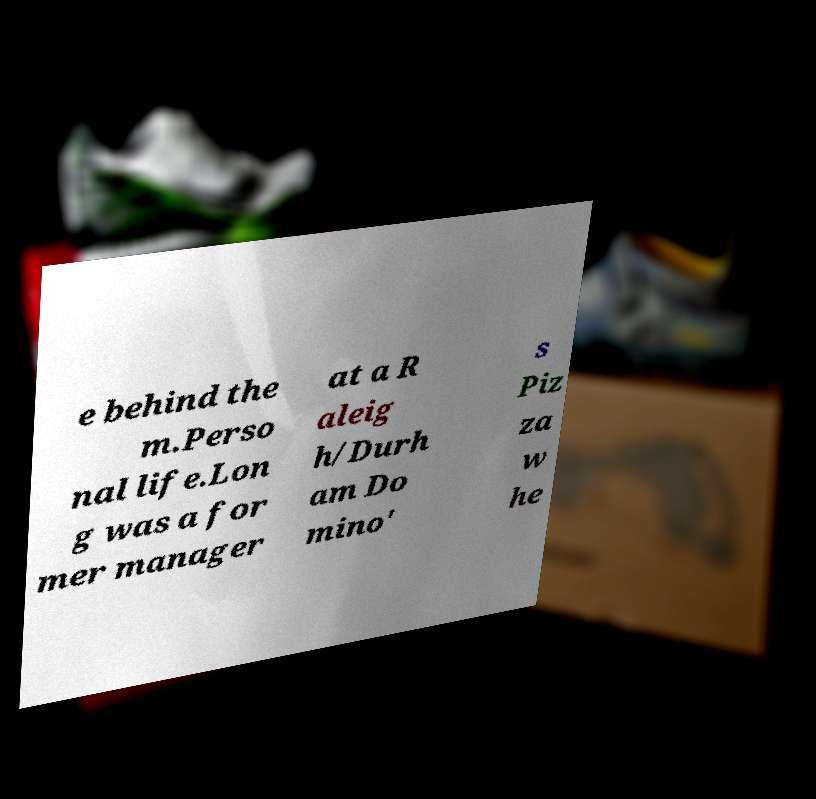There's text embedded in this image that I need extracted. Can you transcribe it verbatim? e behind the m.Perso nal life.Lon g was a for mer manager at a R aleig h/Durh am Do mino' s Piz za w he 